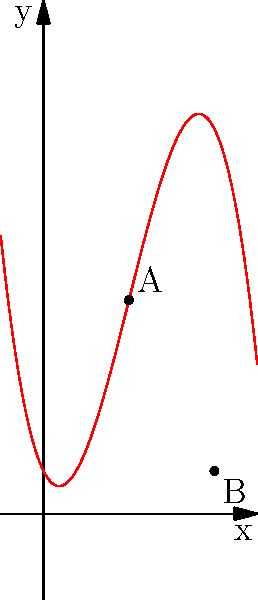The graph of a polynomial function $f(x)$ is shown above. Point A represents the local maximum, and point B represents the local minimum of the function. Given the flexibility in your new professional role, you're tasked with optimizing a process that follows this polynomial behavior. What are the x-coordinates of points A and B? To find the x-coordinates of the local maximum and minimum points:

1. Identify the local maximum point (A):
   The x-coordinate of point A is 2.

2. Identify the local minimum point (B):
   The x-coordinate of point B is 4.

3. In the context of process optimization:
   - The local maximum (A) represents the point of highest efficiency or output.
   - The local minimum (B) represents the point of lowest efficiency or output.

4. These points are crucial for understanding the behavior of the process and making informed decisions about when to adjust parameters or allocate resources.

5. In a flexible work environment, you might use this information to:
   - Schedule peak productivity times around x = 2
   - Plan maintenance or less critical tasks around x = 4
   - Develop strategies to maintain performance closer to the maximum point

By identifying these key points, you can optimize your workflow and demonstrate value in your new professional role.
Answer: x = 2 and x = 4 